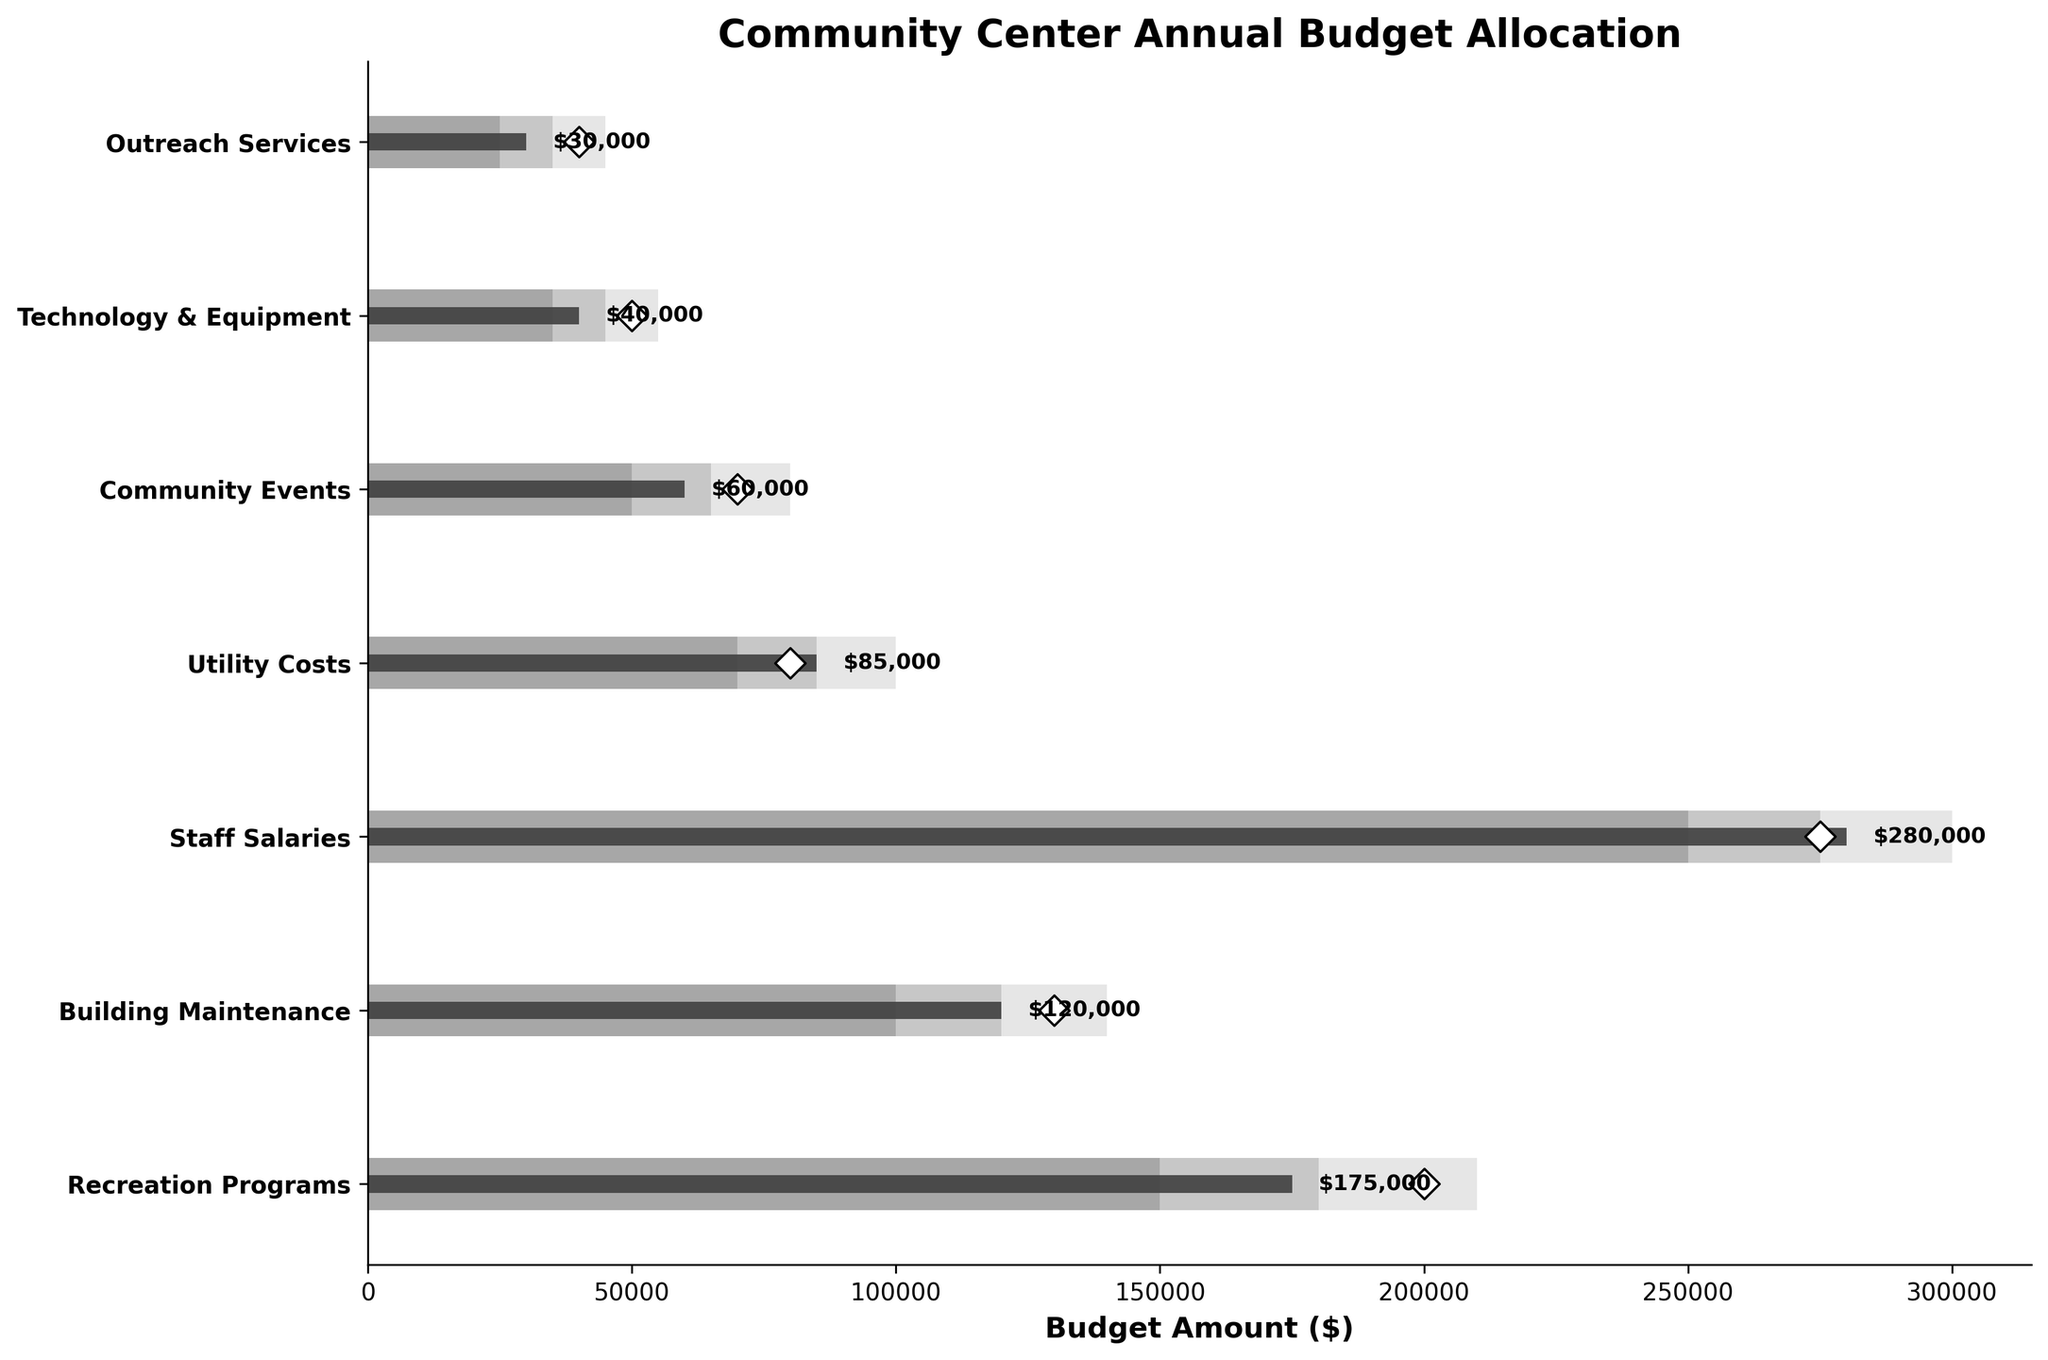What is the title of the plot? The title can be found at the top of the plot, indicating the subject of the data presented.
Answer: Community Center Annual Budget Allocation Which department has the highest actual budget allocation? By observing the lengths of the dark bars (actual values), we can see which one extends the farthest to the right.
Answer: Staff Salaries How much less did Recreation Programs receive compared to its target? Find the actual value for Recreation Programs and subtract it from its target value: 200,000 - 175,000.
Answer: $25,000 Which department's actual budget significantly exceeds its target? Compare the target value (diamond markers) and actual value (dark bars) for each department to identify which one has an actual amount greater than its target.
Answer: Staff Salaries How many departments have actual budget allocations exceeding their mid-range value? We identify the departments where the actual value (dark bar) exceeds the middle range (second bar from the left).
Answer: 4 What is the difference between the actual and target budget for Community Events? Calculate by subtracting the actual value from the target value: 70,000 - 60,000.
Answer: $10,000 Find the average target budget for all departments. Sum all target budgets and divide by the number of departments: (200,000 + 130,000 + 275,000 + 80,000 + 70,000 + 50,000 + 40,000) / 7.
Answer: $120,714 Which department has the smallest range difference between Range 1 and Range 3? Calculate the range difference (Range3 - Range1) for each department and identify the smallest: 210,000-150,000, 140,000-100,000, 300,000-250,000, etc.
Answer: Technology & Equipment Does any department's actual budget fall exactly on its target? Compare each department’s actual value to its target, finding any matches.
Answer: No Which department's actual budget is closest to its target? Calculate the absolute difference between each department's actual and target budgets and identify the smallest difference.
Answer: Utility Costs 